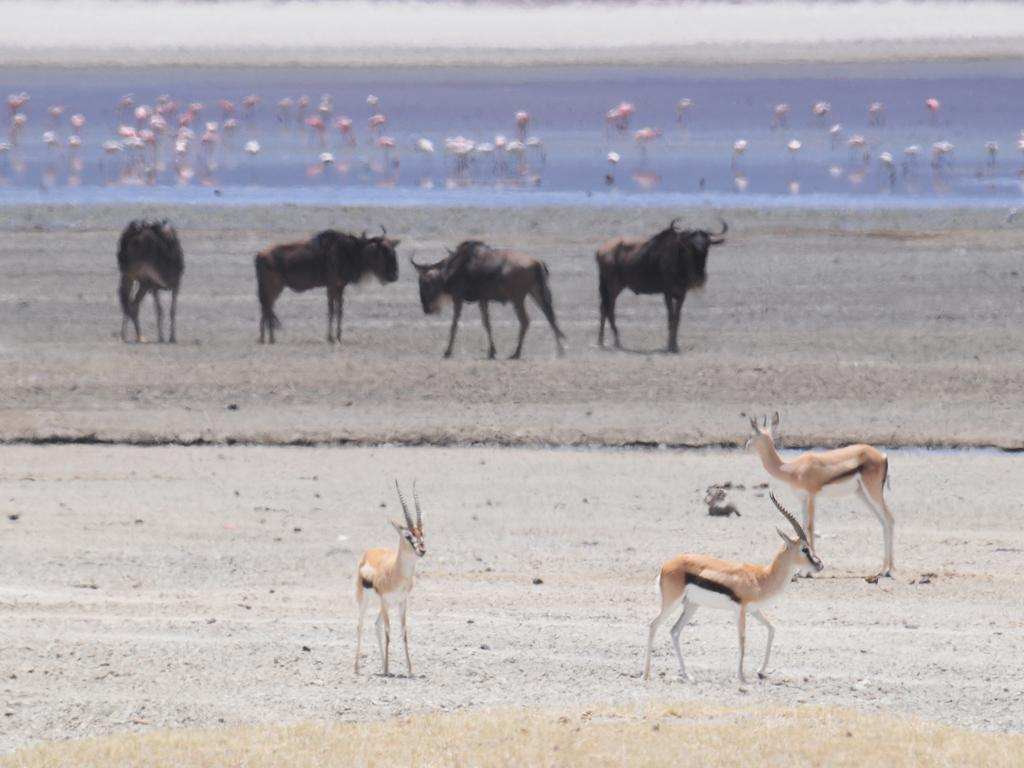What type of animals can be seen on the ground in the image? The specific type of animals cannot be determined from the provided facts, but there are animals on the ground in the image. What can be seen in addition to the animals on the ground? There is water visible in the image, as well as other objects. Can you describe the water in the image? The facts do not provide enough information to describe the water in detail, but it is visible in the image. How many times do the animals laugh in the image? There is no indication that the animals are laughing in the image, as laughter is a human behavior and not applicable to animals. 